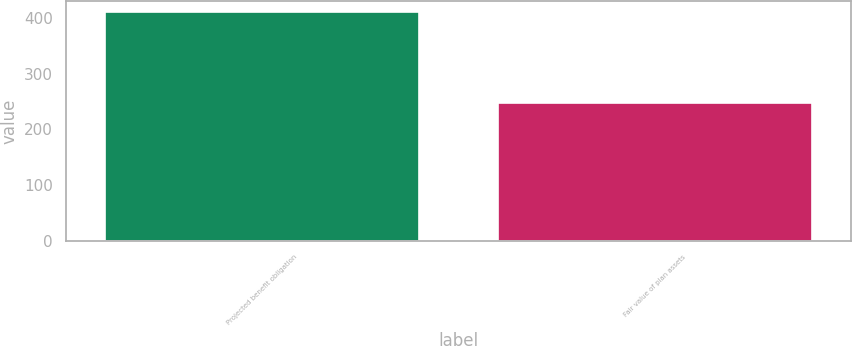Convert chart to OTSL. <chart><loc_0><loc_0><loc_500><loc_500><bar_chart><fcel>Projected benefit obligation<fcel>Fair value of plan assets<nl><fcel>410<fcel>248<nl></chart> 